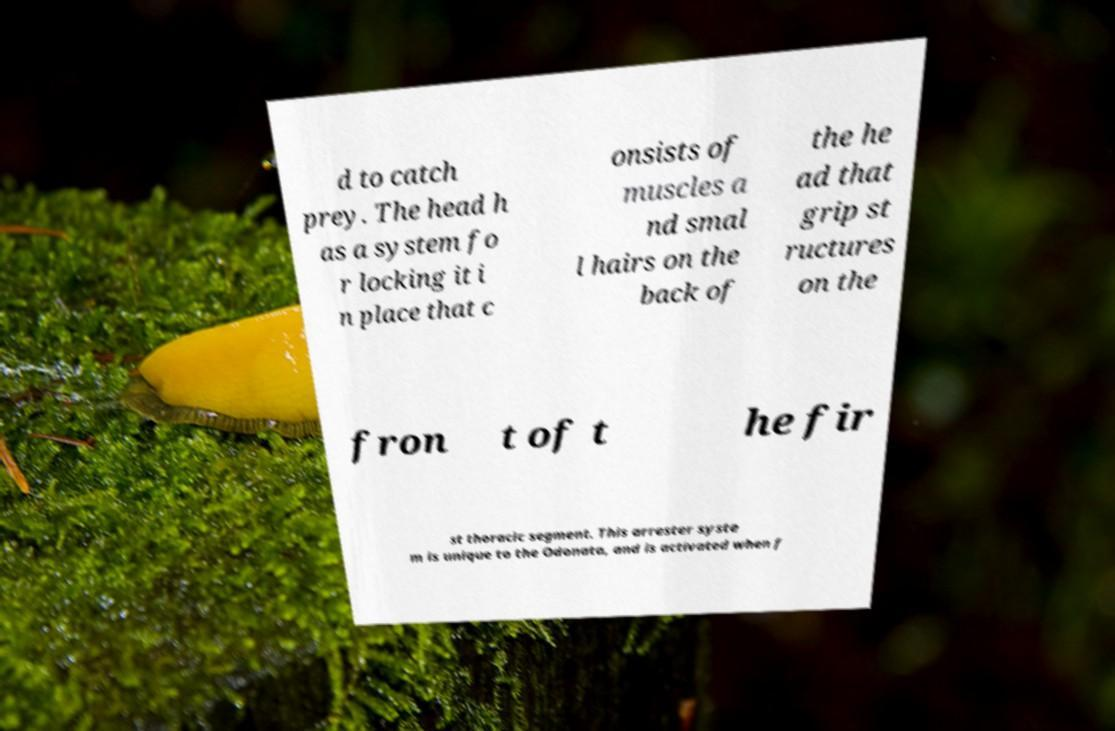Can you accurately transcribe the text from the provided image for me? d to catch prey. The head h as a system fo r locking it i n place that c onsists of muscles a nd smal l hairs on the back of the he ad that grip st ructures on the fron t of t he fir st thoracic segment. This arrester syste m is unique to the Odonata, and is activated when f 